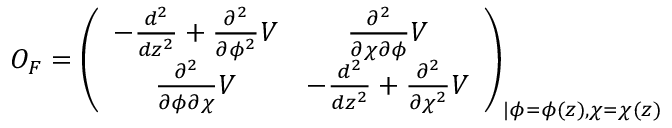<formula> <loc_0><loc_0><loc_500><loc_500>O _ { F } = \left ( \begin{array} { c c } { { - \frac { d ^ { 2 } } { d z ^ { 2 } } + \frac { \partial ^ { 2 } } { \partial \phi ^ { 2 } } V } } & { { \frac { \partial ^ { 2 } } { \partial \chi \partial \phi } V } } \\ { { \frac { \partial ^ { 2 } } { \partial \phi \partial \chi } V } } & { { - \frac { d ^ { 2 } } { d z ^ { 2 } } + \frac { \partial ^ { 2 } } { \partial \chi ^ { 2 } } V } } \end{array} \right ) _ { | \phi = \phi ( z ) , \chi = \chi ( z ) }</formula> 